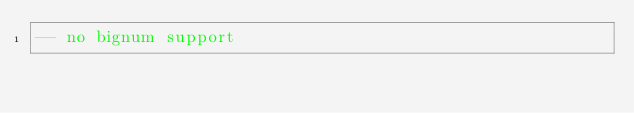<code> <loc_0><loc_0><loc_500><loc_500><_SQL_>-- no bignum support
</code> 